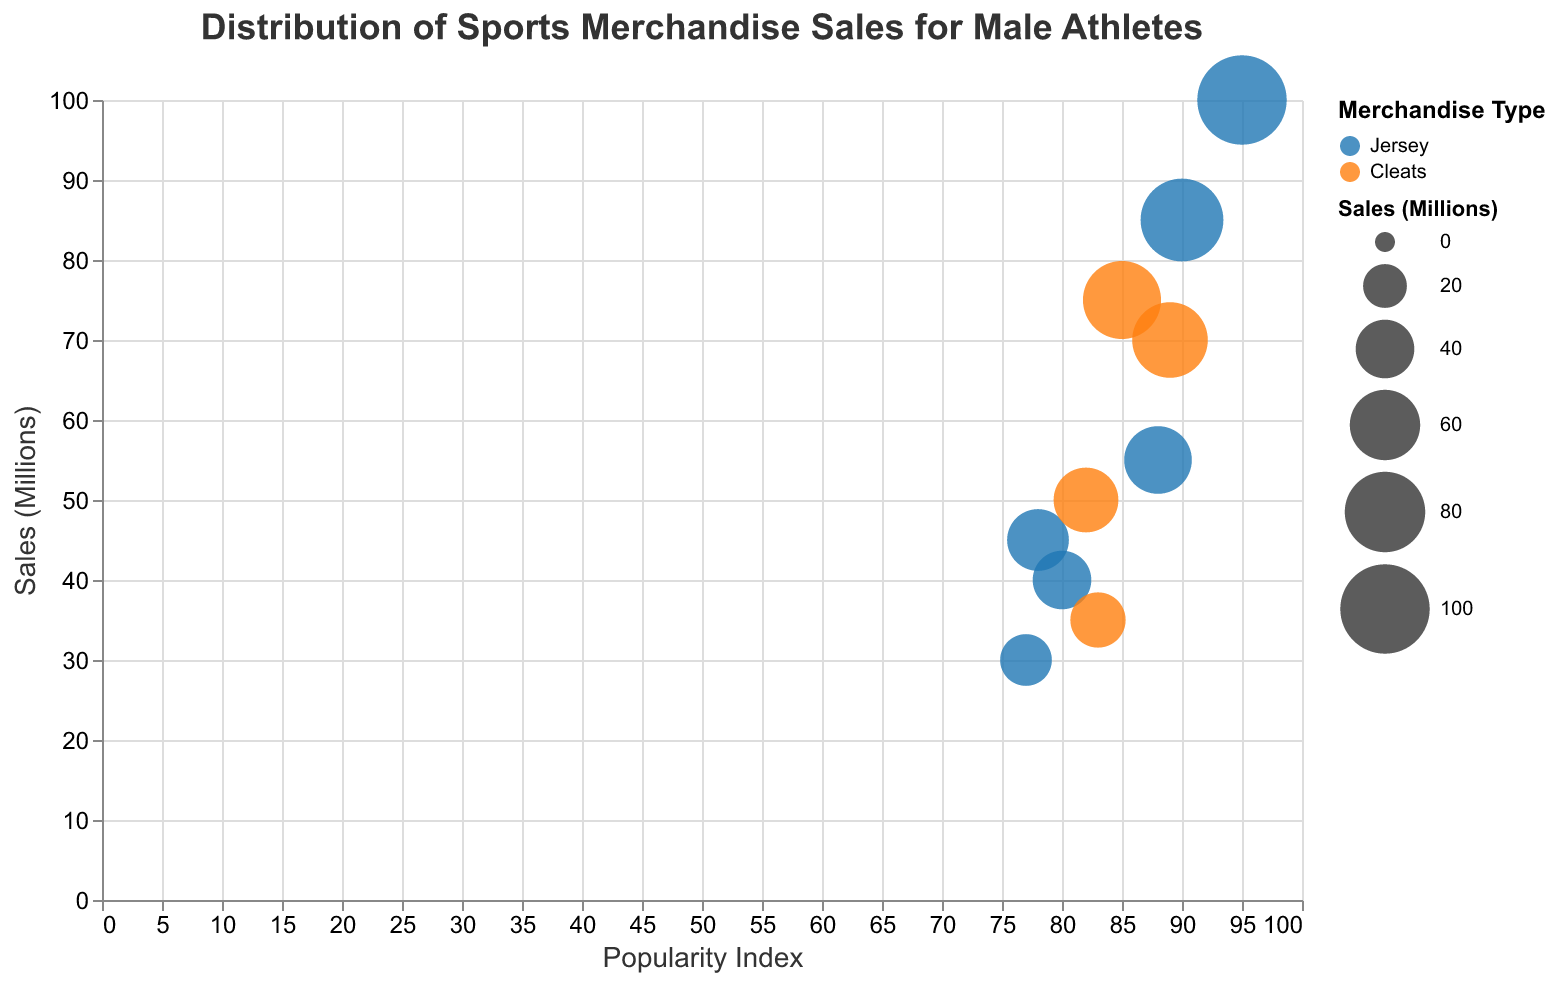Which athlete has the highest sales? The athlete with the highest sales can be identified by finding the data point with the highest y-value (Sales (Millions)). LeBron James has the highest y-value, which is 100 million.
Answer: LeBron James What is the most common merchandise type among sold items? To determine the most common merchandise type, count the occurrences of each category. The categories visible are "Jersey" and "Cleats". "Jersey" appears more frequently.
Answer: Jersey Who has the highest popularity index and what is their merchandise type? Look at the x-axis (Popularity Index) to find the data point farthest to the right. LeBron James has a popularity index of 95 and his merchandise type is "Jersey".
Answer: LeBron James, Jersey Which athlete sells cleats but has the lowest sales? Identify athletes who sell "Cleats" by their bubble color and find the one with the lowest y-value (Sales (Millions)). Kylian Mbappé sells cleats and has the lowest sales at 35 million.
Answer: Kylian Mbappé How do the sales of Aaron Rodgers compare to Kevin Durant? Check the y-axis (Sales (Millions)) values for both athletes. Aaron Rodgers has sales of 40 million, and Kevin Durant has sales of 45 million. Kevin Durant outsells Aaron Rodgers by 5 million.
Answer: Kevin Durant outsells Aaron Rodgers by 5 million What’s the average sales figure for athletes selling jerseys? Add up the sales values for athletes selling jerseys (100 + 85 + 55 + 45 + 40 + 30) and divide by the number of athletes (6). The total is 355, and the average is 355 divided by 6, which is approximately 59.17 million.
Answer: 59.17 million Which athlete has a popularity index closest to 80 but above it? Identify athletes with popularity indices close to but above 80 by looking at the x-axis. Aaron Rodgers has a popularity index of 80, which is closest to but essentially 80.
Answer: Aaron Rodgers For jersey merchandise, who has the highest sales and how much is it? Filter the bubbles by the merchandise type color representing "Jersey" and find the one with the highest y-value. LeBron James has the highest sales for jerseys at 100 million.
Answer: LeBron James, 100 million Which team has the most athletes in this chart? Count the occurrences of each team based on the athlete's team labels in the tooltip. Paris Saint-Germain has the most athletes with 3 (Messi, Neymar Jr., and Mbappé).
Answer: Paris Saint-Germain How does Stephen Curry's sales compare to the average sales of athletes selling cleats? First, find Stephen Curry’s sales (55 million). Then, calculate the average sales for cleats: (75 + 70 + 50 + 35) / 4 = 57.5 million. Curry’s sales are slightly below the average cleat sales.
Answer: Stephen Curry's sales are slightly below average at 55 million compared to 57.5 million 